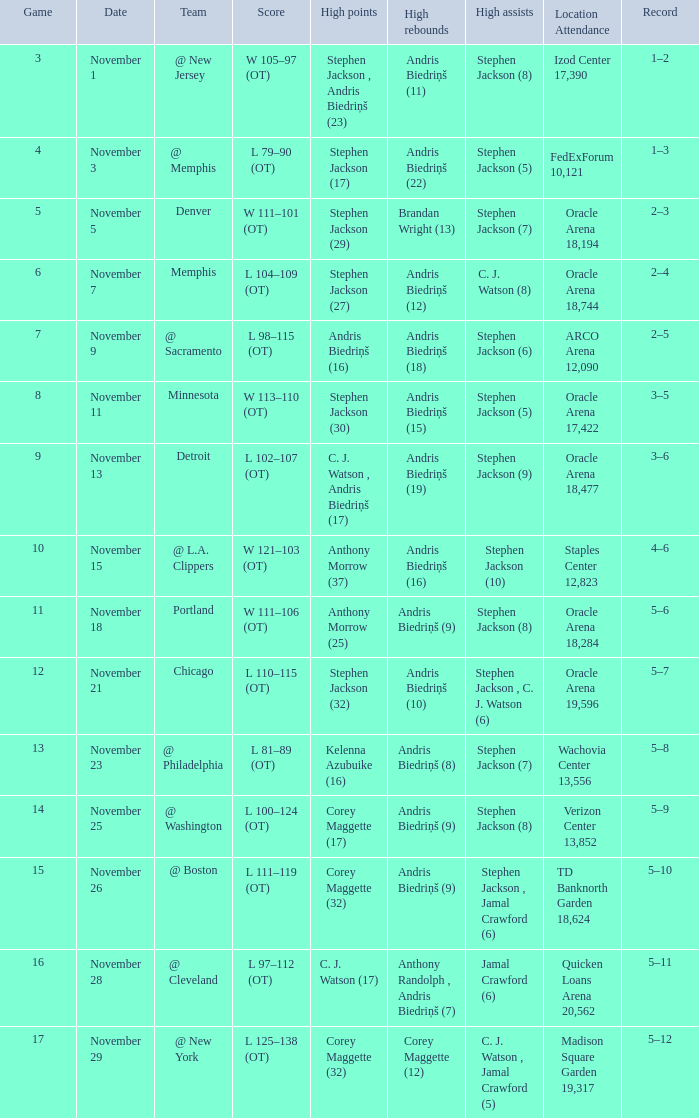What was the game number that was played on November 15? 10.0. 